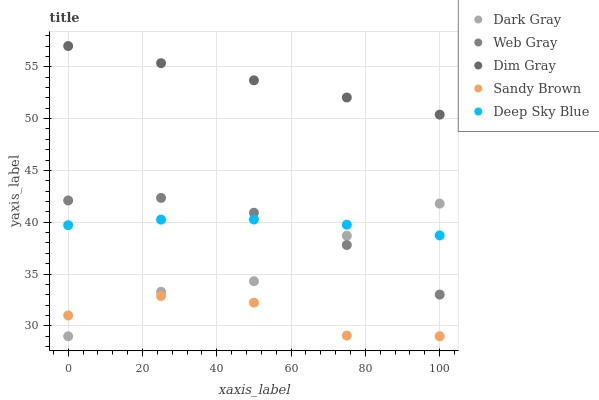Does Sandy Brown have the minimum area under the curve?
Answer yes or no. Yes. Does Dim Gray have the maximum area under the curve?
Answer yes or no. Yes. Does Web Gray have the minimum area under the curve?
Answer yes or no. No. Does Web Gray have the maximum area under the curve?
Answer yes or no. No. Is Dim Gray the smoothest?
Answer yes or no. Yes. Is Sandy Brown the roughest?
Answer yes or no. Yes. Is Web Gray the smoothest?
Answer yes or no. No. Is Web Gray the roughest?
Answer yes or no. No. Does Dark Gray have the lowest value?
Answer yes or no. Yes. Does Web Gray have the lowest value?
Answer yes or no. No. Does Dim Gray have the highest value?
Answer yes or no. Yes. Does Web Gray have the highest value?
Answer yes or no. No. Is Sandy Brown less than Dim Gray?
Answer yes or no. Yes. Is Dim Gray greater than Web Gray?
Answer yes or no. Yes. Does Deep Sky Blue intersect Dark Gray?
Answer yes or no. Yes. Is Deep Sky Blue less than Dark Gray?
Answer yes or no. No. Is Deep Sky Blue greater than Dark Gray?
Answer yes or no. No. Does Sandy Brown intersect Dim Gray?
Answer yes or no. No. 